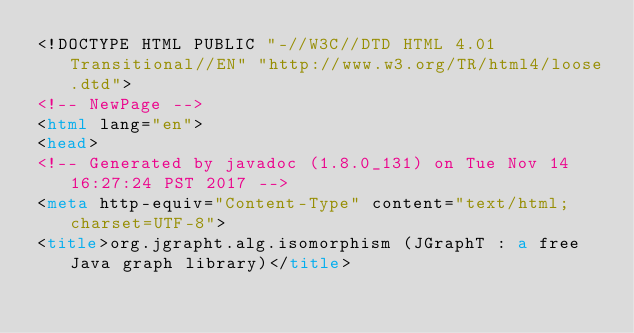Convert code to text. <code><loc_0><loc_0><loc_500><loc_500><_HTML_><!DOCTYPE HTML PUBLIC "-//W3C//DTD HTML 4.01 Transitional//EN" "http://www.w3.org/TR/html4/loose.dtd">
<!-- NewPage -->
<html lang="en">
<head>
<!-- Generated by javadoc (1.8.0_131) on Tue Nov 14 16:27:24 PST 2017 -->
<meta http-equiv="Content-Type" content="text/html; charset=UTF-8">
<title>org.jgrapht.alg.isomorphism (JGraphT : a free Java graph library)</title></code> 